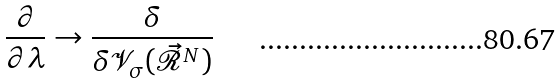<formula> <loc_0><loc_0><loc_500><loc_500>\frac { \partial } { \partial \lambda } \rightarrow \frac { \delta } { \delta \mathcal { V } _ { \sigma } ( \vec { \mathcal { R } } ^ { N } ) }</formula> 